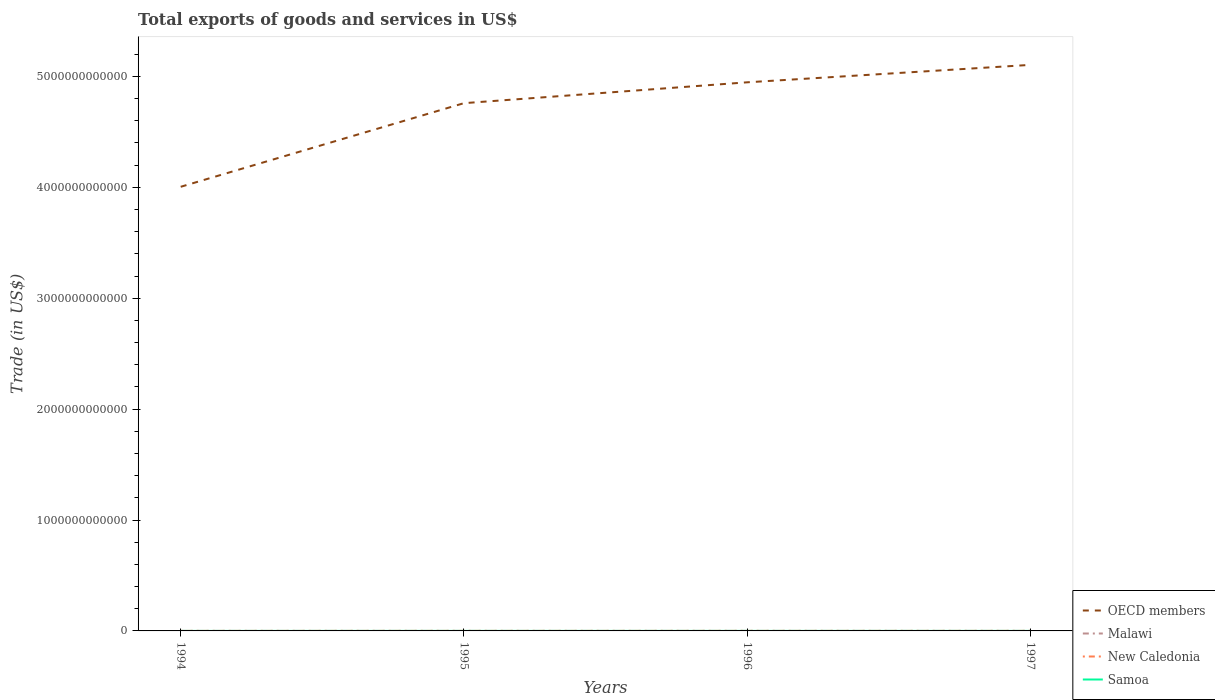Does the line corresponding to OECD members intersect with the line corresponding to Samoa?
Make the answer very short. No. Across all years, what is the maximum total exports of goods and services in Samoa?
Provide a short and direct response. 4.63e+07. In which year was the total exports of goods and services in New Caledonia maximum?
Offer a terse response. 1994. What is the total total exports of goods and services in Samoa in the graph?
Provide a succinct answer. -2.31e+07. What is the difference between the highest and the second highest total exports of goods and services in Malawi?
Give a very brief answer. 2.19e+08. What is the difference between the highest and the lowest total exports of goods and services in New Caledonia?
Offer a terse response. 3. How many years are there in the graph?
Make the answer very short. 4. What is the difference between two consecutive major ticks on the Y-axis?
Offer a very short reply. 1.00e+12. Are the values on the major ticks of Y-axis written in scientific E-notation?
Make the answer very short. No. Does the graph contain any zero values?
Give a very brief answer. No. How many legend labels are there?
Make the answer very short. 4. How are the legend labels stacked?
Give a very brief answer. Vertical. What is the title of the graph?
Provide a short and direct response. Total exports of goods and services in US$. Does "Malaysia" appear as one of the legend labels in the graph?
Your response must be concise. No. What is the label or title of the X-axis?
Ensure brevity in your answer.  Years. What is the label or title of the Y-axis?
Keep it short and to the point. Trade (in US$). What is the Trade (in US$) in OECD members in 1994?
Your answer should be compact. 4.00e+12. What is the Trade (in US$) in Malawi in 1994?
Keep it short and to the point. 3.50e+08. What is the Trade (in US$) of New Caledonia in 1994?
Offer a terse response. 4.13e+08. What is the Trade (in US$) in Samoa in 1994?
Offer a very short reply. 4.63e+07. What is the Trade (in US$) of OECD members in 1995?
Offer a terse response. 4.76e+12. What is the Trade (in US$) of Malawi in 1995?
Make the answer very short. 4.24e+08. What is the Trade (in US$) in New Caledonia in 1995?
Give a very brief answer. 5.65e+08. What is the Trade (in US$) of Samoa in 1995?
Offer a terse response. 6.94e+07. What is the Trade (in US$) of OECD members in 1996?
Your answer should be very brief. 4.95e+12. What is the Trade (in US$) in Malawi in 1996?
Offer a very short reply. 5.21e+08. What is the Trade (in US$) of New Caledonia in 1996?
Give a very brief answer. 5.54e+08. What is the Trade (in US$) of Samoa in 1996?
Provide a succinct answer. 7.87e+07. What is the Trade (in US$) of OECD members in 1997?
Your answer should be very brief. 5.10e+12. What is the Trade (in US$) of Malawi in 1997?
Keep it short and to the point. 5.69e+08. What is the Trade (in US$) in New Caledonia in 1997?
Your answer should be very brief. 5.43e+08. What is the Trade (in US$) of Samoa in 1997?
Offer a terse response. 8.32e+07. Across all years, what is the maximum Trade (in US$) in OECD members?
Make the answer very short. 5.10e+12. Across all years, what is the maximum Trade (in US$) of Malawi?
Give a very brief answer. 5.69e+08. Across all years, what is the maximum Trade (in US$) of New Caledonia?
Your response must be concise. 5.65e+08. Across all years, what is the maximum Trade (in US$) in Samoa?
Your response must be concise. 8.32e+07. Across all years, what is the minimum Trade (in US$) of OECD members?
Ensure brevity in your answer.  4.00e+12. Across all years, what is the minimum Trade (in US$) of Malawi?
Ensure brevity in your answer.  3.50e+08. Across all years, what is the minimum Trade (in US$) of New Caledonia?
Give a very brief answer. 4.13e+08. Across all years, what is the minimum Trade (in US$) in Samoa?
Offer a terse response. 4.63e+07. What is the total Trade (in US$) of OECD members in the graph?
Keep it short and to the point. 1.88e+13. What is the total Trade (in US$) in Malawi in the graph?
Offer a very short reply. 1.86e+09. What is the total Trade (in US$) of New Caledonia in the graph?
Provide a succinct answer. 2.07e+09. What is the total Trade (in US$) of Samoa in the graph?
Ensure brevity in your answer.  2.78e+08. What is the difference between the Trade (in US$) in OECD members in 1994 and that in 1995?
Offer a very short reply. -7.54e+11. What is the difference between the Trade (in US$) of Malawi in 1994 and that in 1995?
Your response must be concise. -7.42e+07. What is the difference between the Trade (in US$) in New Caledonia in 1994 and that in 1995?
Keep it short and to the point. -1.52e+08. What is the difference between the Trade (in US$) of Samoa in 1994 and that in 1995?
Your answer should be compact. -2.31e+07. What is the difference between the Trade (in US$) of OECD members in 1994 and that in 1996?
Ensure brevity in your answer.  -9.42e+11. What is the difference between the Trade (in US$) in Malawi in 1994 and that in 1996?
Keep it short and to the point. -1.70e+08. What is the difference between the Trade (in US$) in New Caledonia in 1994 and that in 1996?
Provide a succinct answer. -1.40e+08. What is the difference between the Trade (in US$) in Samoa in 1994 and that in 1996?
Provide a succinct answer. -3.24e+07. What is the difference between the Trade (in US$) in OECD members in 1994 and that in 1997?
Your response must be concise. -1.10e+12. What is the difference between the Trade (in US$) of Malawi in 1994 and that in 1997?
Your answer should be compact. -2.19e+08. What is the difference between the Trade (in US$) of New Caledonia in 1994 and that in 1997?
Make the answer very short. -1.30e+08. What is the difference between the Trade (in US$) in Samoa in 1994 and that in 1997?
Ensure brevity in your answer.  -3.69e+07. What is the difference between the Trade (in US$) of OECD members in 1995 and that in 1996?
Your answer should be very brief. -1.88e+11. What is the difference between the Trade (in US$) in Malawi in 1995 and that in 1996?
Your response must be concise. -9.63e+07. What is the difference between the Trade (in US$) of New Caledonia in 1995 and that in 1996?
Ensure brevity in your answer.  1.12e+07. What is the difference between the Trade (in US$) in Samoa in 1995 and that in 1996?
Offer a terse response. -9.36e+06. What is the difference between the Trade (in US$) of OECD members in 1995 and that in 1997?
Make the answer very short. -3.45e+11. What is the difference between the Trade (in US$) in Malawi in 1995 and that in 1997?
Provide a short and direct response. -1.44e+08. What is the difference between the Trade (in US$) in New Caledonia in 1995 and that in 1997?
Your answer should be compact. 2.19e+07. What is the difference between the Trade (in US$) in Samoa in 1995 and that in 1997?
Offer a very short reply. -1.38e+07. What is the difference between the Trade (in US$) of OECD members in 1996 and that in 1997?
Offer a very short reply. -1.57e+11. What is the difference between the Trade (in US$) in Malawi in 1996 and that in 1997?
Make the answer very short. -4.81e+07. What is the difference between the Trade (in US$) of New Caledonia in 1996 and that in 1997?
Your response must be concise. 1.07e+07. What is the difference between the Trade (in US$) in Samoa in 1996 and that in 1997?
Make the answer very short. -4.46e+06. What is the difference between the Trade (in US$) of OECD members in 1994 and the Trade (in US$) of Malawi in 1995?
Ensure brevity in your answer.  4.00e+12. What is the difference between the Trade (in US$) of OECD members in 1994 and the Trade (in US$) of New Caledonia in 1995?
Your response must be concise. 4.00e+12. What is the difference between the Trade (in US$) of OECD members in 1994 and the Trade (in US$) of Samoa in 1995?
Provide a short and direct response. 4.00e+12. What is the difference between the Trade (in US$) in Malawi in 1994 and the Trade (in US$) in New Caledonia in 1995?
Your response must be concise. -2.15e+08. What is the difference between the Trade (in US$) of Malawi in 1994 and the Trade (in US$) of Samoa in 1995?
Offer a very short reply. 2.81e+08. What is the difference between the Trade (in US$) of New Caledonia in 1994 and the Trade (in US$) of Samoa in 1995?
Your response must be concise. 3.44e+08. What is the difference between the Trade (in US$) of OECD members in 1994 and the Trade (in US$) of Malawi in 1996?
Offer a very short reply. 4.00e+12. What is the difference between the Trade (in US$) in OECD members in 1994 and the Trade (in US$) in New Caledonia in 1996?
Offer a very short reply. 4.00e+12. What is the difference between the Trade (in US$) of OECD members in 1994 and the Trade (in US$) of Samoa in 1996?
Your answer should be compact. 4.00e+12. What is the difference between the Trade (in US$) in Malawi in 1994 and the Trade (in US$) in New Caledonia in 1996?
Offer a terse response. -2.03e+08. What is the difference between the Trade (in US$) of Malawi in 1994 and the Trade (in US$) of Samoa in 1996?
Provide a succinct answer. 2.71e+08. What is the difference between the Trade (in US$) in New Caledonia in 1994 and the Trade (in US$) in Samoa in 1996?
Provide a succinct answer. 3.34e+08. What is the difference between the Trade (in US$) of OECD members in 1994 and the Trade (in US$) of Malawi in 1997?
Provide a short and direct response. 4.00e+12. What is the difference between the Trade (in US$) in OECD members in 1994 and the Trade (in US$) in New Caledonia in 1997?
Your answer should be very brief. 4.00e+12. What is the difference between the Trade (in US$) of OECD members in 1994 and the Trade (in US$) of Samoa in 1997?
Your response must be concise. 4.00e+12. What is the difference between the Trade (in US$) in Malawi in 1994 and the Trade (in US$) in New Caledonia in 1997?
Keep it short and to the point. -1.93e+08. What is the difference between the Trade (in US$) of Malawi in 1994 and the Trade (in US$) of Samoa in 1997?
Make the answer very short. 2.67e+08. What is the difference between the Trade (in US$) in New Caledonia in 1994 and the Trade (in US$) in Samoa in 1997?
Provide a short and direct response. 3.30e+08. What is the difference between the Trade (in US$) of OECD members in 1995 and the Trade (in US$) of Malawi in 1996?
Provide a short and direct response. 4.76e+12. What is the difference between the Trade (in US$) in OECD members in 1995 and the Trade (in US$) in New Caledonia in 1996?
Give a very brief answer. 4.76e+12. What is the difference between the Trade (in US$) in OECD members in 1995 and the Trade (in US$) in Samoa in 1996?
Make the answer very short. 4.76e+12. What is the difference between the Trade (in US$) of Malawi in 1995 and the Trade (in US$) of New Caledonia in 1996?
Provide a succinct answer. -1.29e+08. What is the difference between the Trade (in US$) of Malawi in 1995 and the Trade (in US$) of Samoa in 1996?
Your response must be concise. 3.46e+08. What is the difference between the Trade (in US$) in New Caledonia in 1995 and the Trade (in US$) in Samoa in 1996?
Keep it short and to the point. 4.86e+08. What is the difference between the Trade (in US$) in OECD members in 1995 and the Trade (in US$) in Malawi in 1997?
Provide a succinct answer. 4.76e+12. What is the difference between the Trade (in US$) of OECD members in 1995 and the Trade (in US$) of New Caledonia in 1997?
Your response must be concise. 4.76e+12. What is the difference between the Trade (in US$) in OECD members in 1995 and the Trade (in US$) in Samoa in 1997?
Offer a very short reply. 4.76e+12. What is the difference between the Trade (in US$) in Malawi in 1995 and the Trade (in US$) in New Caledonia in 1997?
Your response must be concise. -1.18e+08. What is the difference between the Trade (in US$) of Malawi in 1995 and the Trade (in US$) of Samoa in 1997?
Give a very brief answer. 3.41e+08. What is the difference between the Trade (in US$) in New Caledonia in 1995 and the Trade (in US$) in Samoa in 1997?
Your answer should be compact. 4.82e+08. What is the difference between the Trade (in US$) in OECD members in 1996 and the Trade (in US$) in Malawi in 1997?
Provide a short and direct response. 4.95e+12. What is the difference between the Trade (in US$) of OECD members in 1996 and the Trade (in US$) of New Caledonia in 1997?
Your response must be concise. 4.95e+12. What is the difference between the Trade (in US$) of OECD members in 1996 and the Trade (in US$) of Samoa in 1997?
Offer a very short reply. 4.95e+12. What is the difference between the Trade (in US$) in Malawi in 1996 and the Trade (in US$) in New Caledonia in 1997?
Offer a very short reply. -2.22e+07. What is the difference between the Trade (in US$) in Malawi in 1996 and the Trade (in US$) in Samoa in 1997?
Give a very brief answer. 4.37e+08. What is the difference between the Trade (in US$) of New Caledonia in 1996 and the Trade (in US$) of Samoa in 1997?
Give a very brief answer. 4.70e+08. What is the average Trade (in US$) of OECD members per year?
Ensure brevity in your answer.  4.70e+12. What is the average Trade (in US$) in Malawi per year?
Give a very brief answer. 4.66e+08. What is the average Trade (in US$) in New Caledonia per year?
Your answer should be compact. 5.19e+08. What is the average Trade (in US$) of Samoa per year?
Provide a succinct answer. 6.94e+07. In the year 1994, what is the difference between the Trade (in US$) of OECD members and Trade (in US$) of Malawi?
Offer a terse response. 4.00e+12. In the year 1994, what is the difference between the Trade (in US$) of OECD members and Trade (in US$) of New Caledonia?
Provide a short and direct response. 4.00e+12. In the year 1994, what is the difference between the Trade (in US$) in OECD members and Trade (in US$) in Samoa?
Make the answer very short. 4.00e+12. In the year 1994, what is the difference between the Trade (in US$) in Malawi and Trade (in US$) in New Caledonia?
Make the answer very short. -6.29e+07. In the year 1994, what is the difference between the Trade (in US$) of Malawi and Trade (in US$) of Samoa?
Your response must be concise. 3.04e+08. In the year 1994, what is the difference between the Trade (in US$) of New Caledonia and Trade (in US$) of Samoa?
Your answer should be compact. 3.67e+08. In the year 1995, what is the difference between the Trade (in US$) of OECD members and Trade (in US$) of Malawi?
Your answer should be compact. 4.76e+12. In the year 1995, what is the difference between the Trade (in US$) in OECD members and Trade (in US$) in New Caledonia?
Your response must be concise. 4.76e+12. In the year 1995, what is the difference between the Trade (in US$) in OECD members and Trade (in US$) in Samoa?
Your answer should be very brief. 4.76e+12. In the year 1995, what is the difference between the Trade (in US$) of Malawi and Trade (in US$) of New Caledonia?
Offer a terse response. -1.40e+08. In the year 1995, what is the difference between the Trade (in US$) of Malawi and Trade (in US$) of Samoa?
Keep it short and to the point. 3.55e+08. In the year 1995, what is the difference between the Trade (in US$) in New Caledonia and Trade (in US$) in Samoa?
Ensure brevity in your answer.  4.95e+08. In the year 1996, what is the difference between the Trade (in US$) of OECD members and Trade (in US$) of Malawi?
Your answer should be compact. 4.95e+12. In the year 1996, what is the difference between the Trade (in US$) of OECD members and Trade (in US$) of New Caledonia?
Your answer should be compact. 4.95e+12. In the year 1996, what is the difference between the Trade (in US$) of OECD members and Trade (in US$) of Samoa?
Provide a short and direct response. 4.95e+12. In the year 1996, what is the difference between the Trade (in US$) of Malawi and Trade (in US$) of New Caledonia?
Give a very brief answer. -3.29e+07. In the year 1996, what is the difference between the Trade (in US$) in Malawi and Trade (in US$) in Samoa?
Provide a succinct answer. 4.42e+08. In the year 1996, what is the difference between the Trade (in US$) of New Caledonia and Trade (in US$) of Samoa?
Make the answer very short. 4.75e+08. In the year 1997, what is the difference between the Trade (in US$) of OECD members and Trade (in US$) of Malawi?
Your answer should be compact. 5.10e+12. In the year 1997, what is the difference between the Trade (in US$) of OECD members and Trade (in US$) of New Caledonia?
Give a very brief answer. 5.10e+12. In the year 1997, what is the difference between the Trade (in US$) in OECD members and Trade (in US$) in Samoa?
Offer a very short reply. 5.10e+12. In the year 1997, what is the difference between the Trade (in US$) in Malawi and Trade (in US$) in New Caledonia?
Your answer should be very brief. 2.59e+07. In the year 1997, what is the difference between the Trade (in US$) of Malawi and Trade (in US$) of Samoa?
Provide a succinct answer. 4.86e+08. In the year 1997, what is the difference between the Trade (in US$) of New Caledonia and Trade (in US$) of Samoa?
Your response must be concise. 4.60e+08. What is the ratio of the Trade (in US$) in OECD members in 1994 to that in 1995?
Provide a succinct answer. 0.84. What is the ratio of the Trade (in US$) in Malawi in 1994 to that in 1995?
Your answer should be very brief. 0.83. What is the ratio of the Trade (in US$) of New Caledonia in 1994 to that in 1995?
Offer a very short reply. 0.73. What is the ratio of the Trade (in US$) of Samoa in 1994 to that in 1995?
Keep it short and to the point. 0.67. What is the ratio of the Trade (in US$) of OECD members in 1994 to that in 1996?
Your answer should be very brief. 0.81. What is the ratio of the Trade (in US$) in Malawi in 1994 to that in 1996?
Provide a succinct answer. 0.67. What is the ratio of the Trade (in US$) of New Caledonia in 1994 to that in 1996?
Your response must be concise. 0.75. What is the ratio of the Trade (in US$) of Samoa in 1994 to that in 1996?
Make the answer very short. 0.59. What is the ratio of the Trade (in US$) of OECD members in 1994 to that in 1997?
Offer a terse response. 0.78. What is the ratio of the Trade (in US$) in Malawi in 1994 to that in 1997?
Give a very brief answer. 0.62. What is the ratio of the Trade (in US$) of New Caledonia in 1994 to that in 1997?
Your answer should be compact. 0.76. What is the ratio of the Trade (in US$) of Samoa in 1994 to that in 1997?
Your answer should be compact. 0.56. What is the ratio of the Trade (in US$) of OECD members in 1995 to that in 1996?
Offer a very short reply. 0.96. What is the ratio of the Trade (in US$) in Malawi in 1995 to that in 1996?
Give a very brief answer. 0.82. What is the ratio of the Trade (in US$) of New Caledonia in 1995 to that in 1996?
Provide a short and direct response. 1.02. What is the ratio of the Trade (in US$) in Samoa in 1995 to that in 1996?
Offer a terse response. 0.88. What is the ratio of the Trade (in US$) in OECD members in 1995 to that in 1997?
Make the answer very short. 0.93. What is the ratio of the Trade (in US$) of Malawi in 1995 to that in 1997?
Provide a succinct answer. 0.75. What is the ratio of the Trade (in US$) in New Caledonia in 1995 to that in 1997?
Ensure brevity in your answer.  1.04. What is the ratio of the Trade (in US$) of Samoa in 1995 to that in 1997?
Your answer should be compact. 0.83. What is the ratio of the Trade (in US$) in OECD members in 1996 to that in 1997?
Your answer should be compact. 0.97. What is the ratio of the Trade (in US$) of Malawi in 1996 to that in 1997?
Make the answer very short. 0.92. What is the ratio of the Trade (in US$) in New Caledonia in 1996 to that in 1997?
Offer a terse response. 1.02. What is the ratio of the Trade (in US$) in Samoa in 1996 to that in 1997?
Offer a terse response. 0.95. What is the difference between the highest and the second highest Trade (in US$) in OECD members?
Your answer should be compact. 1.57e+11. What is the difference between the highest and the second highest Trade (in US$) in Malawi?
Offer a terse response. 4.81e+07. What is the difference between the highest and the second highest Trade (in US$) of New Caledonia?
Your response must be concise. 1.12e+07. What is the difference between the highest and the second highest Trade (in US$) of Samoa?
Keep it short and to the point. 4.46e+06. What is the difference between the highest and the lowest Trade (in US$) of OECD members?
Provide a succinct answer. 1.10e+12. What is the difference between the highest and the lowest Trade (in US$) in Malawi?
Your answer should be compact. 2.19e+08. What is the difference between the highest and the lowest Trade (in US$) of New Caledonia?
Provide a short and direct response. 1.52e+08. What is the difference between the highest and the lowest Trade (in US$) in Samoa?
Give a very brief answer. 3.69e+07. 